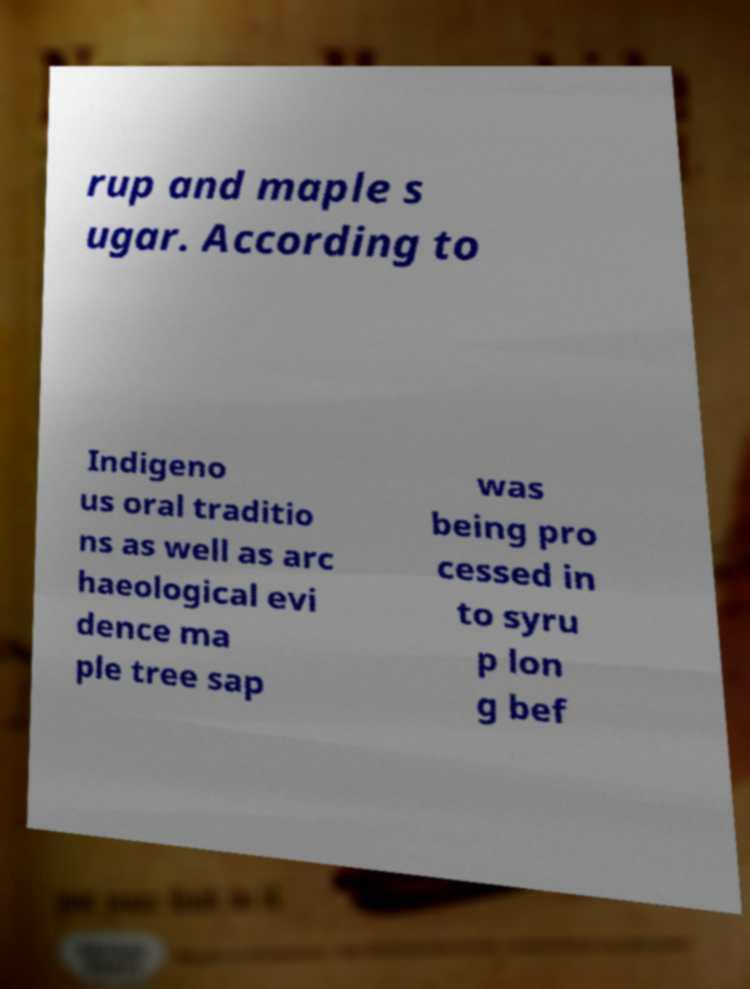For documentation purposes, I need the text within this image transcribed. Could you provide that? rup and maple s ugar. According to Indigeno us oral traditio ns as well as arc haeological evi dence ma ple tree sap was being pro cessed in to syru p lon g bef 